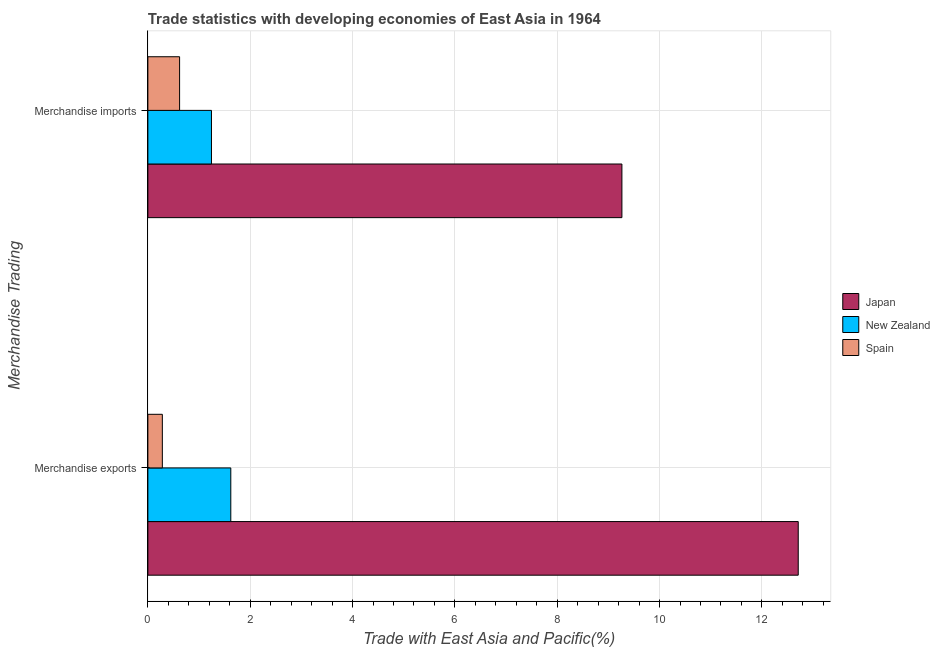How many groups of bars are there?
Offer a terse response. 2. Are the number of bars per tick equal to the number of legend labels?
Keep it short and to the point. Yes. How many bars are there on the 1st tick from the top?
Ensure brevity in your answer.  3. How many bars are there on the 2nd tick from the bottom?
Your response must be concise. 3. What is the merchandise imports in Spain?
Make the answer very short. 0.62. Across all countries, what is the maximum merchandise exports?
Your response must be concise. 12.71. Across all countries, what is the minimum merchandise exports?
Your response must be concise. 0.28. In which country was the merchandise exports minimum?
Make the answer very short. Spain. What is the total merchandise exports in the graph?
Your answer should be compact. 14.61. What is the difference between the merchandise exports in Spain and that in Japan?
Provide a short and direct response. -12.43. What is the difference between the merchandise imports in New Zealand and the merchandise exports in Spain?
Your answer should be very brief. 0.96. What is the average merchandise exports per country?
Ensure brevity in your answer.  4.87. What is the difference between the merchandise imports and merchandise exports in Japan?
Make the answer very short. -3.45. What is the ratio of the merchandise imports in Japan to that in New Zealand?
Provide a succinct answer. 7.45. What does the 3rd bar from the bottom in Merchandise exports represents?
Your response must be concise. Spain. Are all the bars in the graph horizontal?
Your answer should be very brief. Yes. How many countries are there in the graph?
Provide a succinct answer. 3. What is the difference between two consecutive major ticks on the X-axis?
Your answer should be compact. 2. How are the legend labels stacked?
Keep it short and to the point. Vertical. What is the title of the graph?
Offer a very short reply. Trade statistics with developing economies of East Asia in 1964. What is the label or title of the X-axis?
Give a very brief answer. Trade with East Asia and Pacific(%). What is the label or title of the Y-axis?
Keep it short and to the point. Merchandise Trading. What is the Trade with East Asia and Pacific(%) in Japan in Merchandise exports?
Ensure brevity in your answer.  12.71. What is the Trade with East Asia and Pacific(%) in New Zealand in Merchandise exports?
Give a very brief answer. 1.62. What is the Trade with East Asia and Pacific(%) of Spain in Merchandise exports?
Make the answer very short. 0.28. What is the Trade with East Asia and Pacific(%) of Japan in Merchandise imports?
Ensure brevity in your answer.  9.26. What is the Trade with East Asia and Pacific(%) of New Zealand in Merchandise imports?
Your answer should be compact. 1.24. What is the Trade with East Asia and Pacific(%) in Spain in Merchandise imports?
Provide a succinct answer. 0.62. Across all Merchandise Trading, what is the maximum Trade with East Asia and Pacific(%) in Japan?
Offer a terse response. 12.71. Across all Merchandise Trading, what is the maximum Trade with East Asia and Pacific(%) in New Zealand?
Provide a succinct answer. 1.62. Across all Merchandise Trading, what is the maximum Trade with East Asia and Pacific(%) in Spain?
Offer a very short reply. 0.62. Across all Merchandise Trading, what is the minimum Trade with East Asia and Pacific(%) of Japan?
Your answer should be compact. 9.26. Across all Merchandise Trading, what is the minimum Trade with East Asia and Pacific(%) in New Zealand?
Your answer should be very brief. 1.24. Across all Merchandise Trading, what is the minimum Trade with East Asia and Pacific(%) of Spain?
Provide a short and direct response. 0.28. What is the total Trade with East Asia and Pacific(%) in Japan in the graph?
Your answer should be very brief. 21.97. What is the total Trade with East Asia and Pacific(%) of New Zealand in the graph?
Offer a terse response. 2.86. What is the total Trade with East Asia and Pacific(%) of Spain in the graph?
Make the answer very short. 0.9. What is the difference between the Trade with East Asia and Pacific(%) in Japan in Merchandise exports and that in Merchandise imports?
Your answer should be compact. 3.45. What is the difference between the Trade with East Asia and Pacific(%) of New Zealand in Merchandise exports and that in Merchandise imports?
Your response must be concise. 0.38. What is the difference between the Trade with East Asia and Pacific(%) of Spain in Merchandise exports and that in Merchandise imports?
Ensure brevity in your answer.  -0.34. What is the difference between the Trade with East Asia and Pacific(%) of Japan in Merchandise exports and the Trade with East Asia and Pacific(%) of New Zealand in Merchandise imports?
Give a very brief answer. 11.47. What is the difference between the Trade with East Asia and Pacific(%) of Japan in Merchandise exports and the Trade with East Asia and Pacific(%) of Spain in Merchandise imports?
Give a very brief answer. 12.09. What is the average Trade with East Asia and Pacific(%) in Japan per Merchandise Trading?
Provide a succinct answer. 10.99. What is the average Trade with East Asia and Pacific(%) in New Zealand per Merchandise Trading?
Your response must be concise. 1.43. What is the average Trade with East Asia and Pacific(%) of Spain per Merchandise Trading?
Keep it short and to the point. 0.45. What is the difference between the Trade with East Asia and Pacific(%) in Japan and Trade with East Asia and Pacific(%) in New Zealand in Merchandise exports?
Ensure brevity in your answer.  11.09. What is the difference between the Trade with East Asia and Pacific(%) in Japan and Trade with East Asia and Pacific(%) in Spain in Merchandise exports?
Give a very brief answer. 12.43. What is the difference between the Trade with East Asia and Pacific(%) in New Zealand and Trade with East Asia and Pacific(%) in Spain in Merchandise exports?
Ensure brevity in your answer.  1.34. What is the difference between the Trade with East Asia and Pacific(%) in Japan and Trade with East Asia and Pacific(%) in New Zealand in Merchandise imports?
Offer a terse response. 8.02. What is the difference between the Trade with East Asia and Pacific(%) in Japan and Trade with East Asia and Pacific(%) in Spain in Merchandise imports?
Give a very brief answer. 8.64. What is the difference between the Trade with East Asia and Pacific(%) of New Zealand and Trade with East Asia and Pacific(%) of Spain in Merchandise imports?
Keep it short and to the point. 0.62. What is the ratio of the Trade with East Asia and Pacific(%) of Japan in Merchandise exports to that in Merchandise imports?
Make the answer very short. 1.37. What is the ratio of the Trade with East Asia and Pacific(%) in New Zealand in Merchandise exports to that in Merchandise imports?
Make the answer very short. 1.3. What is the ratio of the Trade with East Asia and Pacific(%) of Spain in Merchandise exports to that in Merchandise imports?
Your answer should be compact. 0.46. What is the difference between the highest and the second highest Trade with East Asia and Pacific(%) in Japan?
Your answer should be compact. 3.45. What is the difference between the highest and the second highest Trade with East Asia and Pacific(%) of New Zealand?
Make the answer very short. 0.38. What is the difference between the highest and the second highest Trade with East Asia and Pacific(%) of Spain?
Keep it short and to the point. 0.34. What is the difference between the highest and the lowest Trade with East Asia and Pacific(%) of Japan?
Your answer should be very brief. 3.45. What is the difference between the highest and the lowest Trade with East Asia and Pacific(%) in New Zealand?
Keep it short and to the point. 0.38. What is the difference between the highest and the lowest Trade with East Asia and Pacific(%) in Spain?
Your response must be concise. 0.34. 